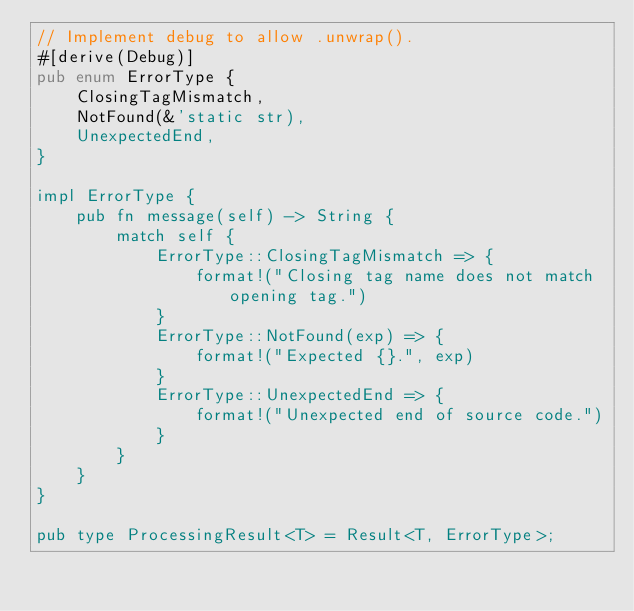<code> <loc_0><loc_0><loc_500><loc_500><_Rust_>// Implement debug to allow .unwrap().
#[derive(Debug)]
pub enum ErrorType {
    ClosingTagMismatch,
    NotFound(&'static str),
    UnexpectedEnd,
}

impl ErrorType {
    pub fn message(self) -> String {
        match self {
            ErrorType::ClosingTagMismatch => {
                format!("Closing tag name does not match opening tag.")
            }
            ErrorType::NotFound(exp) => {
                format!("Expected {}.", exp)
            }
            ErrorType::UnexpectedEnd => {
                format!("Unexpected end of source code.")
            }
        }
    }
}

pub type ProcessingResult<T> = Result<T, ErrorType>;
</code> 